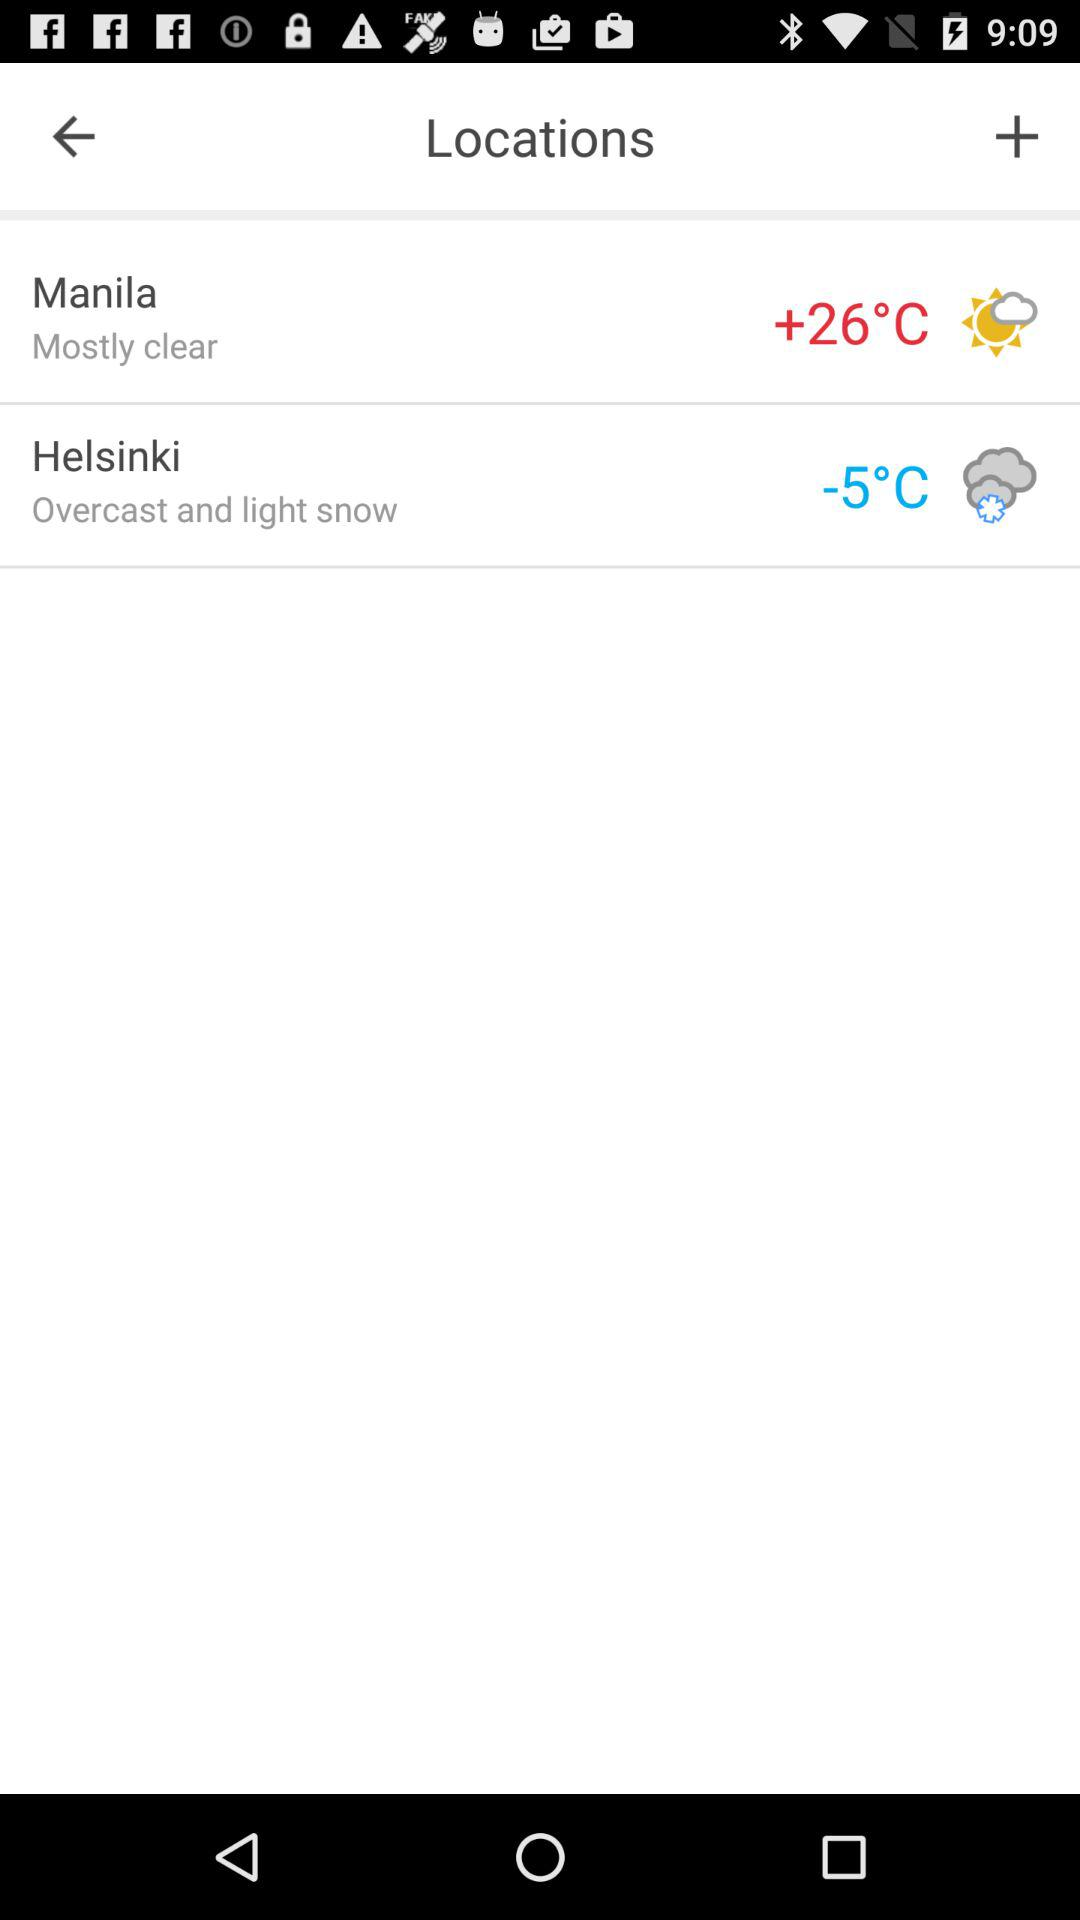Which location has the temperature of -5 degrees Celsius? The location is Helsinki. 